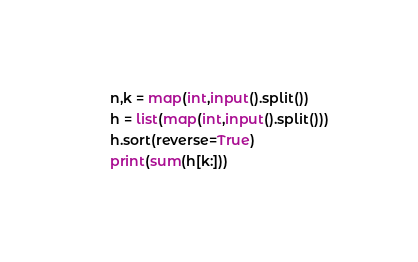Convert code to text. <code><loc_0><loc_0><loc_500><loc_500><_Python_>n,k = map(int,input().split())
h = list(map(int,input().split()))
h.sort(reverse=True)
print(sum(h[k:]))</code> 